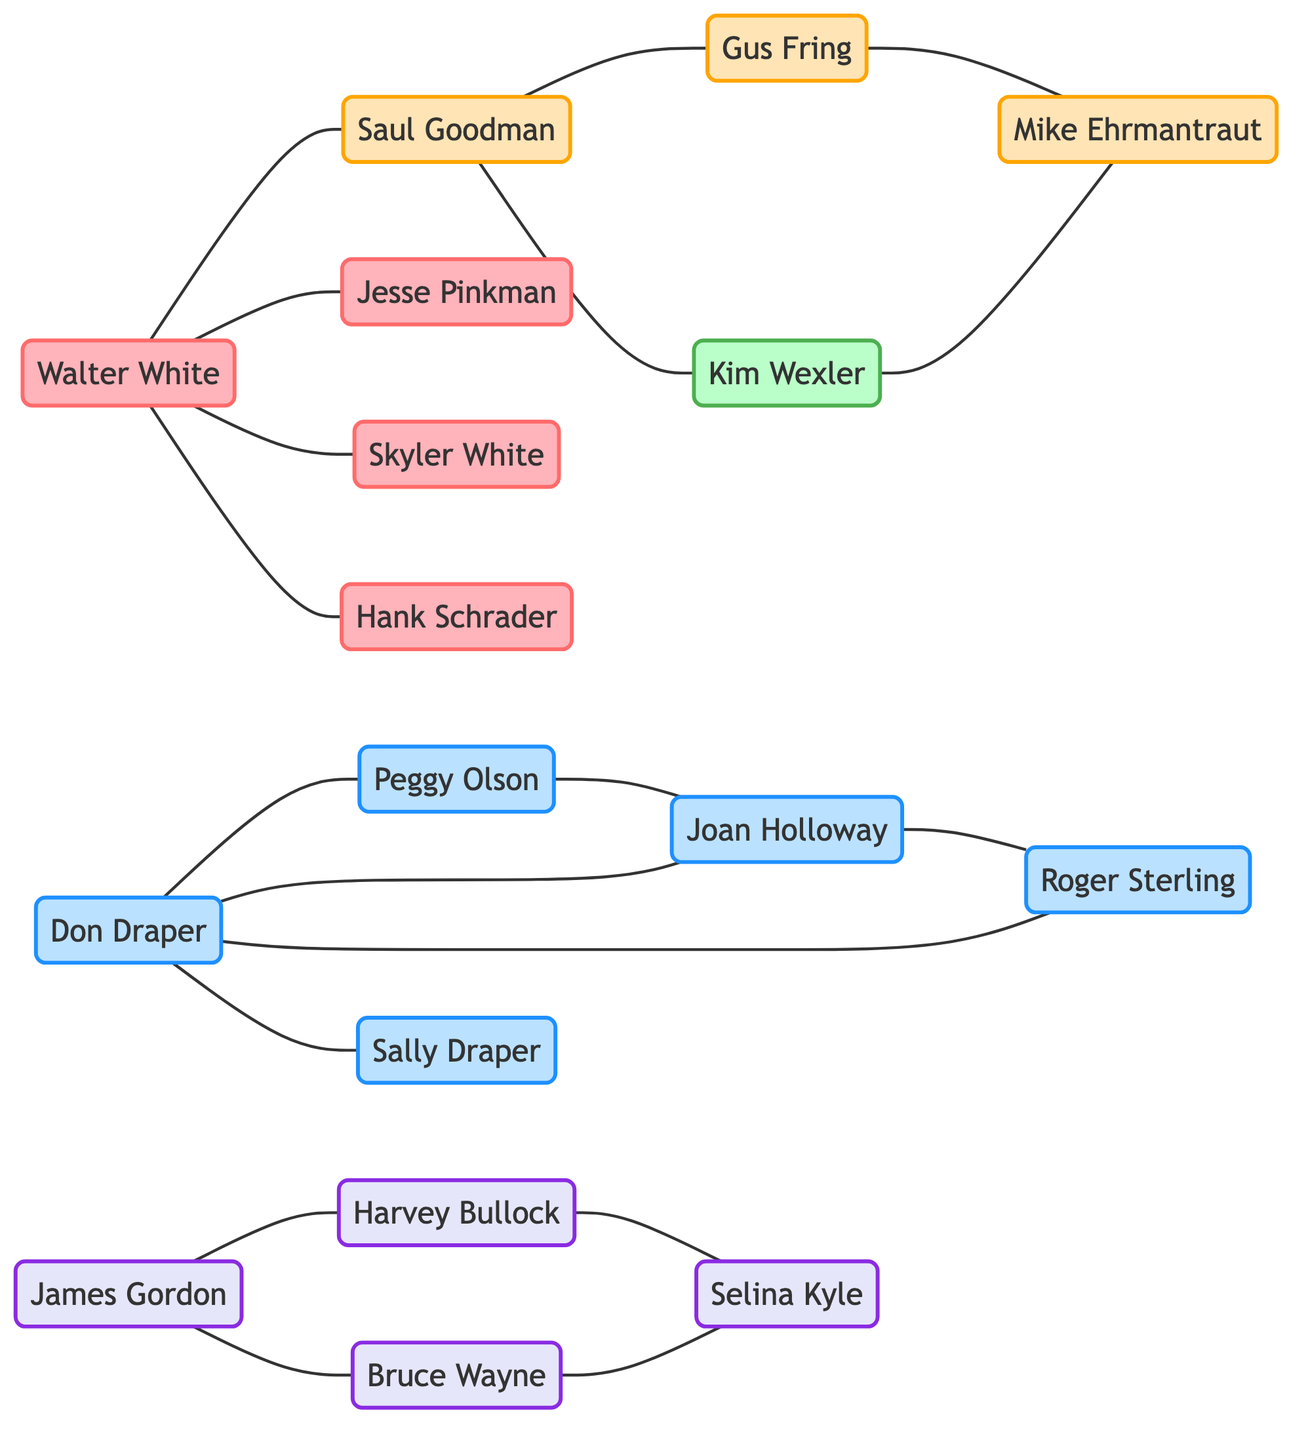What is the total number of nodes in the graph? By counting the unique character nodes provided in the data, we identify that there are 16 distinct individuals from various TV shows represented.
Answer: 16 Which character is directly connected to Walter White? The connections listed show that Walter White has direct links to three characters: Saul Goodman, Jesse Pinkman, and Skyler White.
Answer: Saul Goodman, Jesse Pinkman, Skyler White How many characters from Mad Men are depicted in the diagram? A review of the nodes indicates that there are five characters associated with Mad Men: Don Draper, Peggy Olson, Joan Holloway, Roger Sterling, and Sally Draper.
Answer: 5 Who is connected to both Saul Goodman and Kim Wexler? The links specify that the character Saul Goodman is directly connected to Gus Fring and Kim Wexler. However, Kim Wexler is only connected to Saul Goodman and Mike Ehrmantraut, meaning that the answer is Kim Wexler.
Answer: Kim Wexler Which character has the most connections in the diagram? By analyzing the connections, Walter White is shown to be linked to five characters: Saul Goodman, Jesse Pinkman, Skyler White, Hank Schrader, and Gus Fring. Therefore, Walter White has the most connections.
Answer: Walter White How many edges does the diagram have? The total edges, representing the relationships between characters, are calculated by counting every link provided in the data, resulting in 16 edges total.
Answer: 16 Which shows are the characters associated with Walter White from? The characters connected to Walter White are all from the show "Breaking Bad" and include Saul Goodman, Jesse Pinkman, and others derived from that series.
Answer: Breaking Bad Is there a direct connection between Don Draper and Joan Holloway? A look at the edges shows that Don Draper is directly linked to Joan Holloway, confirming their connection in the network.
Answer: Yes How many characters interact with Bruce Wayne? The analysis of Bruce Wayne's connections shows he interacts with two characters: James Gordon and Selina Kyle.
Answer: 2 